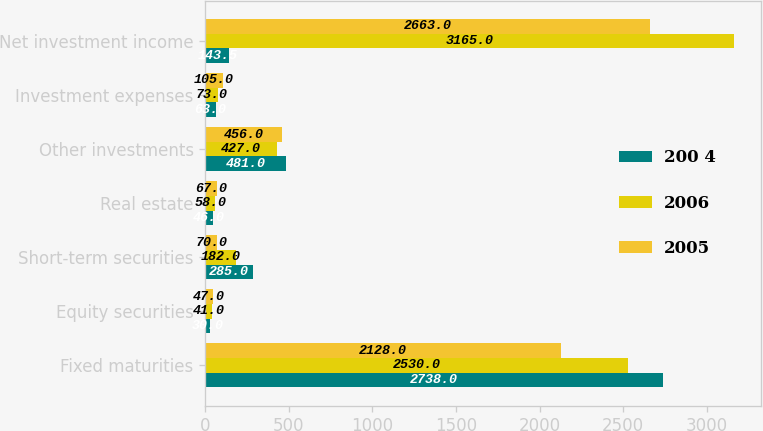Convert chart. <chart><loc_0><loc_0><loc_500><loc_500><stacked_bar_chart><ecel><fcel>Fixed maturities<fcel>Equity securities<fcel>Short-term securities<fcel>Real estate<fcel>Other investments<fcel>Investment expenses<fcel>Net investment income<nl><fcel>200 4<fcel>2738<fcel>30<fcel>285<fcel>46<fcel>481<fcel>63<fcel>143.5<nl><fcel>2006<fcel>2530<fcel>41<fcel>182<fcel>58<fcel>427<fcel>73<fcel>3165<nl><fcel>2005<fcel>2128<fcel>47<fcel>70<fcel>67<fcel>456<fcel>105<fcel>2663<nl></chart> 